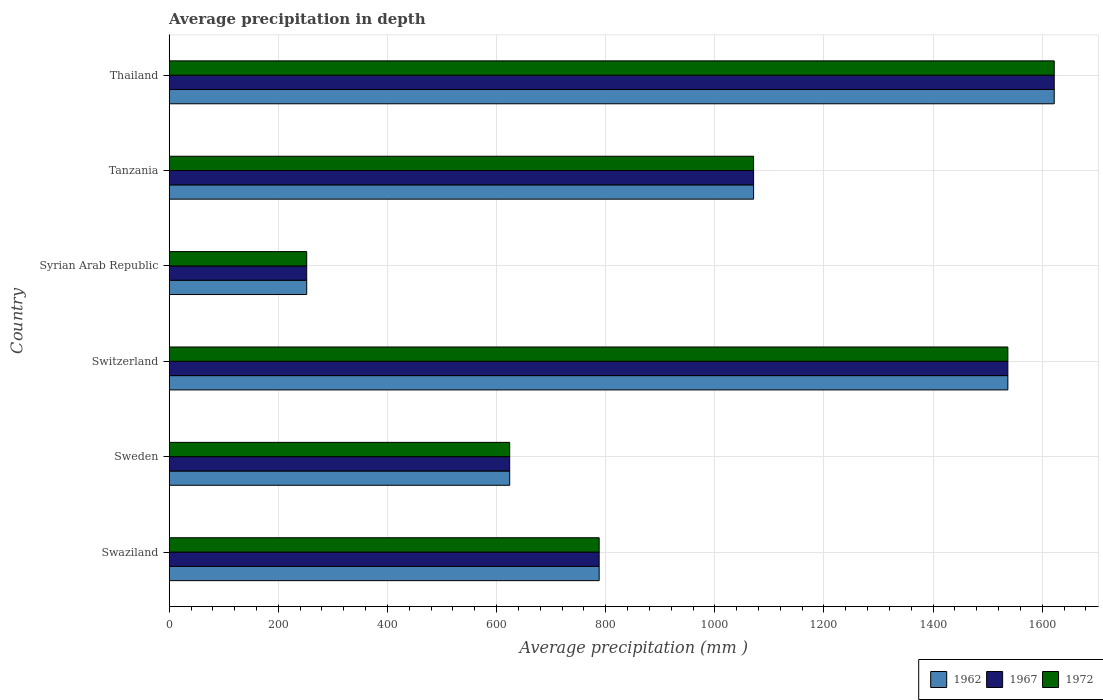How many groups of bars are there?
Offer a terse response. 6. Are the number of bars per tick equal to the number of legend labels?
Ensure brevity in your answer.  Yes. How many bars are there on the 4th tick from the top?
Ensure brevity in your answer.  3. What is the label of the 3rd group of bars from the top?
Keep it short and to the point. Syrian Arab Republic. What is the average precipitation in 1962 in Swaziland?
Provide a short and direct response. 788. Across all countries, what is the maximum average precipitation in 1962?
Provide a short and direct response. 1622. Across all countries, what is the minimum average precipitation in 1962?
Offer a very short reply. 252. In which country was the average precipitation in 1972 maximum?
Your answer should be compact. Thailand. In which country was the average precipitation in 1972 minimum?
Keep it short and to the point. Syrian Arab Republic. What is the total average precipitation in 1962 in the graph?
Give a very brief answer. 5894. What is the difference between the average precipitation in 1962 in Swaziland and that in Sweden?
Provide a succinct answer. 164. What is the difference between the average precipitation in 1972 in Syrian Arab Republic and the average precipitation in 1962 in Swaziland?
Your answer should be compact. -536. What is the average average precipitation in 1967 per country?
Offer a terse response. 982.33. What is the difference between the average precipitation in 1967 and average precipitation in 1962 in Thailand?
Make the answer very short. 0. In how many countries, is the average precipitation in 1972 greater than 800 mm?
Your answer should be compact. 3. What is the ratio of the average precipitation in 1967 in Sweden to that in Thailand?
Give a very brief answer. 0.38. Is the difference between the average precipitation in 1967 in Sweden and Switzerland greater than the difference between the average precipitation in 1962 in Sweden and Switzerland?
Offer a terse response. No. What is the difference between the highest and the lowest average precipitation in 1972?
Your answer should be very brief. 1370. In how many countries, is the average precipitation in 1967 greater than the average average precipitation in 1967 taken over all countries?
Provide a short and direct response. 3. Is the sum of the average precipitation in 1967 in Swaziland and Thailand greater than the maximum average precipitation in 1962 across all countries?
Offer a terse response. Yes. What does the 2nd bar from the top in Sweden represents?
Offer a terse response. 1967. How many bars are there?
Offer a terse response. 18. Does the graph contain any zero values?
Your response must be concise. No. Does the graph contain grids?
Your response must be concise. Yes. What is the title of the graph?
Give a very brief answer. Average precipitation in depth. What is the label or title of the X-axis?
Provide a short and direct response. Average precipitation (mm ). What is the label or title of the Y-axis?
Your response must be concise. Country. What is the Average precipitation (mm ) in 1962 in Swaziland?
Ensure brevity in your answer.  788. What is the Average precipitation (mm ) of 1967 in Swaziland?
Ensure brevity in your answer.  788. What is the Average precipitation (mm ) in 1972 in Swaziland?
Give a very brief answer. 788. What is the Average precipitation (mm ) of 1962 in Sweden?
Your answer should be compact. 624. What is the Average precipitation (mm ) in 1967 in Sweden?
Your response must be concise. 624. What is the Average precipitation (mm ) in 1972 in Sweden?
Your answer should be compact. 624. What is the Average precipitation (mm ) in 1962 in Switzerland?
Your response must be concise. 1537. What is the Average precipitation (mm ) of 1967 in Switzerland?
Offer a terse response. 1537. What is the Average precipitation (mm ) in 1972 in Switzerland?
Your answer should be compact. 1537. What is the Average precipitation (mm ) in 1962 in Syrian Arab Republic?
Give a very brief answer. 252. What is the Average precipitation (mm ) of 1967 in Syrian Arab Republic?
Give a very brief answer. 252. What is the Average precipitation (mm ) of 1972 in Syrian Arab Republic?
Ensure brevity in your answer.  252. What is the Average precipitation (mm ) in 1962 in Tanzania?
Offer a very short reply. 1071. What is the Average precipitation (mm ) in 1967 in Tanzania?
Your answer should be compact. 1071. What is the Average precipitation (mm ) in 1972 in Tanzania?
Provide a short and direct response. 1071. What is the Average precipitation (mm ) of 1962 in Thailand?
Offer a terse response. 1622. What is the Average precipitation (mm ) in 1967 in Thailand?
Ensure brevity in your answer.  1622. What is the Average precipitation (mm ) of 1972 in Thailand?
Offer a very short reply. 1622. Across all countries, what is the maximum Average precipitation (mm ) of 1962?
Provide a short and direct response. 1622. Across all countries, what is the maximum Average precipitation (mm ) in 1967?
Make the answer very short. 1622. Across all countries, what is the maximum Average precipitation (mm ) of 1972?
Your response must be concise. 1622. Across all countries, what is the minimum Average precipitation (mm ) in 1962?
Offer a terse response. 252. Across all countries, what is the minimum Average precipitation (mm ) of 1967?
Offer a very short reply. 252. Across all countries, what is the minimum Average precipitation (mm ) of 1972?
Keep it short and to the point. 252. What is the total Average precipitation (mm ) in 1962 in the graph?
Offer a very short reply. 5894. What is the total Average precipitation (mm ) in 1967 in the graph?
Provide a short and direct response. 5894. What is the total Average precipitation (mm ) of 1972 in the graph?
Give a very brief answer. 5894. What is the difference between the Average precipitation (mm ) of 1962 in Swaziland and that in Sweden?
Provide a succinct answer. 164. What is the difference between the Average precipitation (mm ) of 1967 in Swaziland and that in Sweden?
Your answer should be compact. 164. What is the difference between the Average precipitation (mm ) of 1972 in Swaziland and that in Sweden?
Make the answer very short. 164. What is the difference between the Average precipitation (mm ) in 1962 in Swaziland and that in Switzerland?
Offer a terse response. -749. What is the difference between the Average precipitation (mm ) in 1967 in Swaziland and that in Switzerland?
Provide a succinct answer. -749. What is the difference between the Average precipitation (mm ) of 1972 in Swaziland and that in Switzerland?
Provide a short and direct response. -749. What is the difference between the Average precipitation (mm ) of 1962 in Swaziland and that in Syrian Arab Republic?
Your answer should be very brief. 536. What is the difference between the Average precipitation (mm ) in 1967 in Swaziland and that in Syrian Arab Republic?
Ensure brevity in your answer.  536. What is the difference between the Average precipitation (mm ) of 1972 in Swaziland and that in Syrian Arab Republic?
Provide a succinct answer. 536. What is the difference between the Average precipitation (mm ) of 1962 in Swaziland and that in Tanzania?
Provide a succinct answer. -283. What is the difference between the Average precipitation (mm ) in 1967 in Swaziland and that in Tanzania?
Offer a terse response. -283. What is the difference between the Average precipitation (mm ) in 1972 in Swaziland and that in Tanzania?
Offer a very short reply. -283. What is the difference between the Average precipitation (mm ) of 1962 in Swaziland and that in Thailand?
Make the answer very short. -834. What is the difference between the Average precipitation (mm ) in 1967 in Swaziland and that in Thailand?
Your response must be concise. -834. What is the difference between the Average precipitation (mm ) in 1972 in Swaziland and that in Thailand?
Your response must be concise. -834. What is the difference between the Average precipitation (mm ) of 1962 in Sweden and that in Switzerland?
Make the answer very short. -913. What is the difference between the Average precipitation (mm ) of 1967 in Sweden and that in Switzerland?
Offer a terse response. -913. What is the difference between the Average precipitation (mm ) of 1972 in Sweden and that in Switzerland?
Offer a very short reply. -913. What is the difference between the Average precipitation (mm ) in 1962 in Sweden and that in Syrian Arab Republic?
Provide a succinct answer. 372. What is the difference between the Average precipitation (mm ) in 1967 in Sweden and that in Syrian Arab Republic?
Make the answer very short. 372. What is the difference between the Average precipitation (mm ) of 1972 in Sweden and that in Syrian Arab Republic?
Your answer should be compact. 372. What is the difference between the Average precipitation (mm ) of 1962 in Sweden and that in Tanzania?
Provide a succinct answer. -447. What is the difference between the Average precipitation (mm ) in 1967 in Sweden and that in Tanzania?
Give a very brief answer. -447. What is the difference between the Average precipitation (mm ) in 1972 in Sweden and that in Tanzania?
Give a very brief answer. -447. What is the difference between the Average precipitation (mm ) in 1962 in Sweden and that in Thailand?
Your answer should be compact. -998. What is the difference between the Average precipitation (mm ) in 1967 in Sweden and that in Thailand?
Your response must be concise. -998. What is the difference between the Average precipitation (mm ) of 1972 in Sweden and that in Thailand?
Offer a terse response. -998. What is the difference between the Average precipitation (mm ) in 1962 in Switzerland and that in Syrian Arab Republic?
Provide a succinct answer. 1285. What is the difference between the Average precipitation (mm ) of 1967 in Switzerland and that in Syrian Arab Republic?
Offer a terse response. 1285. What is the difference between the Average precipitation (mm ) in 1972 in Switzerland and that in Syrian Arab Republic?
Make the answer very short. 1285. What is the difference between the Average precipitation (mm ) in 1962 in Switzerland and that in Tanzania?
Offer a terse response. 466. What is the difference between the Average precipitation (mm ) in 1967 in Switzerland and that in Tanzania?
Provide a short and direct response. 466. What is the difference between the Average precipitation (mm ) of 1972 in Switzerland and that in Tanzania?
Keep it short and to the point. 466. What is the difference between the Average precipitation (mm ) of 1962 in Switzerland and that in Thailand?
Ensure brevity in your answer.  -85. What is the difference between the Average precipitation (mm ) of 1967 in Switzerland and that in Thailand?
Make the answer very short. -85. What is the difference between the Average precipitation (mm ) in 1972 in Switzerland and that in Thailand?
Ensure brevity in your answer.  -85. What is the difference between the Average precipitation (mm ) of 1962 in Syrian Arab Republic and that in Tanzania?
Provide a succinct answer. -819. What is the difference between the Average precipitation (mm ) in 1967 in Syrian Arab Republic and that in Tanzania?
Provide a short and direct response. -819. What is the difference between the Average precipitation (mm ) in 1972 in Syrian Arab Republic and that in Tanzania?
Provide a succinct answer. -819. What is the difference between the Average precipitation (mm ) of 1962 in Syrian Arab Republic and that in Thailand?
Offer a terse response. -1370. What is the difference between the Average precipitation (mm ) in 1967 in Syrian Arab Republic and that in Thailand?
Provide a short and direct response. -1370. What is the difference between the Average precipitation (mm ) in 1972 in Syrian Arab Republic and that in Thailand?
Offer a very short reply. -1370. What is the difference between the Average precipitation (mm ) of 1962 in Tanzania and that in Thailand?
Your response must be concise. -551. What is the difference between the Average precipitation (mm ) of 1967 in Tanzania and that in Thailand?
Ensure brevity in your answer.  -551. What is the difference between the Average precipitation (mm ) of 1972 in Tanzania and that in Thailand?
Offer a terse response. -551. What is the difference between the Average precipitation (mm ) in 1962 in Swaziland and the Average precipitation (mm ) in 1967 in Sweden?
Provide a short and direct response. 164. What is the difference between the Average precipitation (mm ) of 1962 in Swaziland and the Average precipitation (mm ) of 1972 in Sweden?
Provide a succinct answer. 164. What is the difference between the Average precipitation (mm ) of 1967 in Swaziland and the Average precipitation (mm ) of 1972 in Sweden?
Your answer should be very brief. 164. What is the difference between the Average precipitation (mm ) of 1962 in Swaziland and the Average precipitation (mm ) of 1967 in Switzerland?
Keep it short and to the point. -749. What is the difference between the Average precipitation (mm ) in 1962 in Swaziland and the Average precipitation (mm ) in 1972 in Switzerland?
Give a very brief answer. -749. What is the difference between the Average precipitation (mm ) in 1967 in Swaziland and the Average precipitation (mm ) in 1972 in Switzerland?
Make the answer very short. -749. What is the difference between the Average precipitation (mm ) of 1962 in Swaziland and the Average precipitation (mm ) of 1967 in Syrian Arab Republic?
Offer a very short reply. 536. What is the difference between the Average precipitation (mm ) in 1962 in Swaziland and the Average precipitation (mm ) in 1972 in Syrian Arab Republic?
Offer a very short reply. 536. What is the difference between the Average precipitation (mm ) in 1967 in Swaziland and the Average precipitation (mm ) in 1972 in Syrian Arab Republic?
Offer a very short reply. 536. What is the difference between the Average precipitation (mm ) in 1962 in Swaziland and the Average precipitation (mm ) in 1967 in Tanzania?
Provide a succinct answer. -283. What is the difference between the Average precipitation (mm ) of 1962 in Swaziland and the Average precipitation (mm ) of 1972 in Tanzania?
Provide a short and direct response. -283. What is the difference between the Average precipitation (mm ) in 1967 in Swaziland and the Average precipitation (mm ) in 1972 in Tanzania?
Your answer should be compact. -283. What is the difference between the Average precipitation (mm ) of 1962 in Swaziland and the Average precipitation (mm ) of 1967 in Thailand?
Your answer should be compact. -834. What is the difference between the Average precipitation (mm ) in 1962 in Swaziland and the Average precipitation (mm ) in 1972 in Thailand?
Ensure brevity in your answer.  -834. What is the difference between the Average precipitation (mm ) in 1967 in Swaziland and the Average precipitation (mm ) in 1972 in Thailand?
Offer a terse response. -834. What is the difference between the Average precipitation (mm ) of 1962 in Sweden and the Average precipitation (mm ) of 1967 in Switzerland?
Provide a short and direct response. -913. What is the difference between the Average precipitation (mm ) in 1962 in Sweden and the Average precipitation (mm ) in 1972 in Switzerland?
Provide a short and direct response. -913. What is the difference between the Average precipitation (mm ) of 1967 in Sweden and the Average precipitation (mm ) of 1972 in Switzerland?
Provide a short and direct response. -913. What is the difference between the Average precipitation (mm ) of 1962 in Sweden and the Average precipitation (mm ) of 1967 in Syrian Arab Republic?
Provide a succinct answer. 372. What is the difference between the Average precipitation (mm ) of 1962 in Sweden and the Average precipitation (mm ) of 1972 in Syrian Arab Republic?
Your response must be concise. 372. What is the difference between the Average precipitation (mm ) in 1967 in Sweden and the Average precipitation (mm ) in 1972 in Syrian Arab Republic?
Ensure brevity in your answer.  372. What is the difference between the Average precipitation (mm ) of 1962 in Sweden and the Average precipitation (mm ) of 1967 in Tanzania?
Offer a very short reply. -447. What is the difference between the Average precipitation (mm ) of 1962 in Sweden and the Average precipitation (mm ) of 1972 in Tanzania?
Your response must be concise. -447. What is the difference between the Average precipitation (mm ) of 1967 in Sweden and the Average precipitation (mm ) of 1972 in Tanzania?
Your answer should be compact. -447. What is the difference between the Average precipitation (mm ) in 1962 in Sweden and the Average precipitation (mm ) in 1967 in Thailand?
Offer a very short reply. -998. What is the difference between the Average precipitation (mm ) in 1962 in Sweden and the Average precipitation (mm ) in 1972 in Thailand?
Ensure brevity in your answer.  -998. What is the difference between the Average precipitation (mm ) in 1967 in Sweden and the Average precipitation (mm ) in 1972 in Thailand?
Make the answer very short. -998. What is the difference between the Average precipitation (mm ) of 1962 in Switzerland and the Average precipitation (mm ) of 1967 in Syrian Arab Republic?
Your answer should be compact. 1285. What is the difference between the Average precipitation (mm ) in 1962 in Switzerland and the Average precipitation (mm ) in 1972 in Syrian Arab Republic?
Make the answer very short. 1285. What is the difference between the Average precipitation (mm ) of 1967 in Switzerland and the Average precipitation (mm ) of 1972 in Syrian Arab Republic?
Ensure brevity in your answer.  1285. What is the difference between the Average precipitation (mm ) in 1962 in Switzerland and the Average precipitation (mm ) in 1967 in Tanzania?
Make the answer very short. 466. What is the difference between the Average precipitation (mm ) in 1962 in Switzerland and the Average precipitation (mm ) in 1972 in Tanzania?
Ensure brevity in your answer.  466. What is the difference between the Average precipitation (mm ) in 1967 in Switzerland and the Average precipitation (mm ) in 1972 in Tanzania?
Provide a succinct answer. 466. What is the difference between the Average precipitation (mm ) of 1962 in Switzerland and the Average precipitation (mm ) of 1967 in Thailand?
Make the answer very short. -85. What is the difference between the Average precipitation (mm ) in 1962 in Switzerland and the Average precipitation (mm ) in 1972 in Thailand?
Provide a succinct answer. -85. What is the difference between the Average precipitation (mm ) in 1967 in Switzerland and the Average precipitation (mm ) in 1972 in Thailand?
Keep it short and to the point. -85. What is the difference between the Average precipitation (mm ) in 1962 in Syrian Arab Republic and the Average precipitation (mm ) in 1967 in Tanzania?
Give a very brief answer. -819. What is the difference between the Average precipitation (mm ) of 1962 in Syrian Arab Republic and the Average precipitation (mm ) of 1972 in Tanzania?
Keep it short and to the point. -819. What is the difference between the Average precipitation (mm ) of 1967 in Syrian Arab Republic and the Average precipitation (mm ) of 1972 in Tanzania?
Your response must be concise. -819. What is the difference between the Average precipitation (mm ) in 1962 in Syrian Arab Republic and the Average precipitation (mm ) in 1967 in Thailand?
Your answer should be compact. -1370. What is the difference between the Average precipitation (mm ) of 1962 in Syrian Arab Republic and the Average precipitation (mm ) of 1972 in Thailand?
Provide a short and direct response. -1370. What is the difference between the Average precipitation (mm ) of 1967 in Syrian Arab Republic and the Average precipitation (mm ) of 1972 in Thailand?
Make the answer very short. -1370. What is the difference between the Average precipitation (mm ) of 1962 in Tanzania and the Average precipitation (mm ) of 1967 in Thailand?
Offer a very short reply. -551. What is the difference between the Average precipitation (mm ) in 1962 in Tanzania and the Average precipitation (mm ) in 1972 in Thailand?
Give a very brief answer. -551. What is the difference between the Average precipitation (mm ) of 1967 in Tanzania and the Average precipitation (mm ) of 1972 in Thailand?
Provide a succinct answer. -551. What is the average Average precipitation (mm ) of 1962 per country?
Your answer should be compact. 982.33. What is the average Average precipitation (mm ) of 1967 per country?
Your answer should be very brief. 982.33. What is the average Average precipitation (mm ) of 1972 per country?
Your answer should be very brief. 982.33. What is the difference between the Average precipitation (mm ) in 1962 and Average precipitation (mm ) in 1967 in Swaziland?
Provide a short and direct response. 0. What is the difference between the Average precipitation (mm ) in 1967 and Average precipitation (mm ) in 1972 in Swaziland?
Your answer should be compact. 0. What is the difference between the Average precipitation (mm ) of 1962 and Average precipitation (mm ) of 1967 in Sweden?
Offer a terse response. 0. What is the difference between the Average precipitation (mm ) of 1962 and Average precipitation (mm ) of 1972 in Sweden?
Your answer should be very brief. 0. What is the difference between the Average precipitation (mm ) of 1962 and Average precipitation (mm ) of 1967 in Switzerland?
Ensure brevity in your answer.  0. What is the difference between the Average precipitation (mm ) in 1962 and Average precipitation (mm ) in 1972 in Switzerland?
Your answer should be very brief. 0. What is the difference between the Average precipitation (mm ) of 1967 and Average precipitation (mm ) of 1972 in Syrian Arab Republic?
Give a very brief answer. 0. What is the difference between the Average precipitation (mm ) in 1967 and Average precipitation (mm ) in 1972 in Tanzania?
Make the answer very short. 0. What is the difference between the Average precipitation (mm ) of 1962 and Average precipitation (mm ) of 1967 in Thailand?
Provide a short and direct response. 0. What is the difference between the Average precipitation (mm ) in 1962 and Average precipitation (mm ) in 1972 in Thailand?
Offer a very short reply. 0. What is the ratio of the Average precipitation (mm ) in 1962 in Swaziland to that in Sweden?
Your answer should be very brief. 1.26. What is the ratio of the Average precipitation (mm ) of 1967 in Swaziland to that in Sweden?
Provide a short and direct response. 1.26. What is the ratio of the Average precipitation (mm ) in 1972 in Swaziland to that in Sweden?
Your answer should be compact. 1.26. What is the ratio of the Average precipitation (mm ) of 1962 in Swaziland to that in Switzerland?
Keep it short and to the point. 0.51. What is the ratio of the Average precipitation (mm ) of 1967 in Swaziland to that in Switzerland?
Keep it short and to the point. 0.51. What is the ratio of the Average precipitation (mm ) of 1972 in Swaziland to that in Switzerland?
Provide a succinct answer. 0.51. What is the ratio of the Average precipitation (mm ) of 1962 in Swaziland to that in Syrian Arab Republic?
Ensure brevity in your answer.  3.13. What is the ratio of the Average precipitation (mm ) in 1967 in Swaziland to that in Syrian Arab Republic?
Your response must be concise. 3.13. What is the ratio of the Average precipitation (mm ) of 1972 in Swaziland to that in Syrian Arab Republic?
Provide a succinct answer. 3.13. What is the ratio of the Average precipitation (mm ) in 1962 in Swaziland to that in Tanzania?
Give a very brief answer. 0.74. What is the ratio of the Average precipitation (mm ) in 1967 in Swaziland to that in Tanzania?
Give a very brief answer. 0.74. What is the ratio of the Average precipitation (mm ) of 1972 in Swaziland to that in Tanzania?
Ensure brevity in your answer.  0.74. What is the ratio of the Average precipitation (mm ) in 1962 in Swaziland to that in Thailand?
Offer a terse response. 0.49. What is the ratio of the Average precipitation (mm ) in 1967 in Swaziland to that in Thailand?
Your answer should be very brief. 0.49. What is the ratio of the Average precipitation (mm ) of 1972 in Swaziland to that in Thailand?
Give a very brief answer. 0.49. What is the ratio of the Average precipitation (mm ) in 1962 in Sweden to that in Switzerland?
Provide a succinct answer. 0.41. What is the ratio of the Average precipitation (mm ) of 1967 in Sweden to that in Switzerland?
Offer a terse response. 0.41. What is the ratio of the Average precipitation (mm ) in 1972 in Sweden to that in Switzerland?
Your answer should be compact. 0.41. What is the ratio of the Average precipitation (mm ) of 1962 in Sweden to that in Syrian Arab Republic?
Your answer should be very brief. 2.48. What is the ratio of the Average precipitation (mm ) of 1967 in Sweden to that in Syrian Arab Republic?
Offer a very short reply. 2.48. What is the ratio of the Average precipitation (mm ) of 1972 in Sweden to that in Syrian Arab Republic?
Your answer should be very brief. 2.48. What is the ratio of the Average precipitation (mm ) of 1962 in Sweden to that in Tanzania?
Your answer should be very brief. 0.58. What is the ratio of the Average precipitation (mm ) of 1967 in Sweden to that in Tanzania?
Offer a very short reply. 0.58. What is the ratio of the Average precipitation (mm ) of 1972 in Sweden to that in Tanzania?
Make the answer very short. 0.58. What is the ratio of the Average precipitation (mm ) of 1962 in Sweden to that in Thailand?
Your answer should be very brief. 0.38. What is the ratio of the Average precipitation (mm ) in 1967 in Sweden to that in Thailand?
Offer a terse response. 0.38. What is the ratio of the Average precipitation (mm ) of 1972 in Sweden to that in Thailand?
Your answer should be very brief. 0.38. What is the ratio of the Average precipitation (mm ) of 1962 in Switzerland to that in Syrian Arab Republic?
Provide a succinct answer. 6.1. What is the ratio of the Average precipitation (mm ) in 1967 in Switzerland to that in Syrian Arab Republic?
Make the answer very short. 6.1. What is the ratio of the Average precipitation (mm ) in 1972 in Switzerland to that in Syrian Arab Republic?
Keep it short and to the point. 6.1. What is the ratio of the Average precipitation (mm ) in 1962 in Switzerland to that in Tanzania?
Offer a terse response. 1.44. What is the ratio of the Average precipitation (mm ) in 1967 in Switzerland to that in Tanzania?
Give a very brief answer. 1.44. What is the ratio of the Average precipitation (mm ) in 1972 in Switzerland to that in Tanzania?
Your response must be concise. 1.44. What is the ratio of the Average precipitation (mm ) of 1962 in Switzerland to that in Thailand?
Provide a succinct answer. 0.95. What is the ratio of the Average precipitation (mm ) of 1967 in Switzerland to that in Thailand?
Offer a terse response. 0.95. What is the ratio of the Average precipitation (mm ) in 1972 in Switzerland to that in Thailand?
Provide a succinct answer. 0.95. What is the ratio of the Average precipitation (mm ) in 1962 in Syrian Arab Republic to that in Tanzania?
Your response must be concise. 0.24. What is the ratio of the Average precipitation (mm ) of 1967 in Syrian Arab Republic to that in Tanzania?
Offer a terse response. 0.24. What is the ratio of the Average precipitation (mm ) in 1972 in Syrian Arab Republic to that in Tanzania?
Keep it short and to the point. 0.24. What is the ratio of the Average precipitation (mm ) of 1962 in Syrian Arab Republic to that in Thailand?
Make the answer very short. 0.16. What is the ratio of the Average precipitation (mm ) of 1967 in Syrian Arab Republic to that in Thailand?
Your answer should be compact. 0.16. What is the ratio of the Average precipitation (mm ) of 1972 in Syrian Arab Republic to that in Thailand?
Ensure brevity in your answer.  0.16. What is the ratio of the Average precipitation (mm ) in 1962 in Tanzania to that in Thailand?
Your answer should be compact. 0.66. What is the ratio of the Average precipitation (mm ) in 1967 in Tanzania to that in Thailand?
Ensure brevity in your answer.  0.66. What is the ratio of the Average precipitation (mm ) in 1972 in Tanzania to that in Thailand?
Your answer should be very brief. 0.66. What is the difference between the highest and the second highest Average precipitation (mm ) in 1962?
Offer a terse response. 85. What is the difference between the highest and the lowest Average precipitation (mm ) in 1962?
Your answer should be compact. 1370. What is the difference between the highest and the lowest Average precipitation (mm ) in 1967?
Provide a succinct answer. 1370. What is the difference between the highest and the lowest Average precipitation (mm ) of 1972?
Give a very brief answer. 1370. 